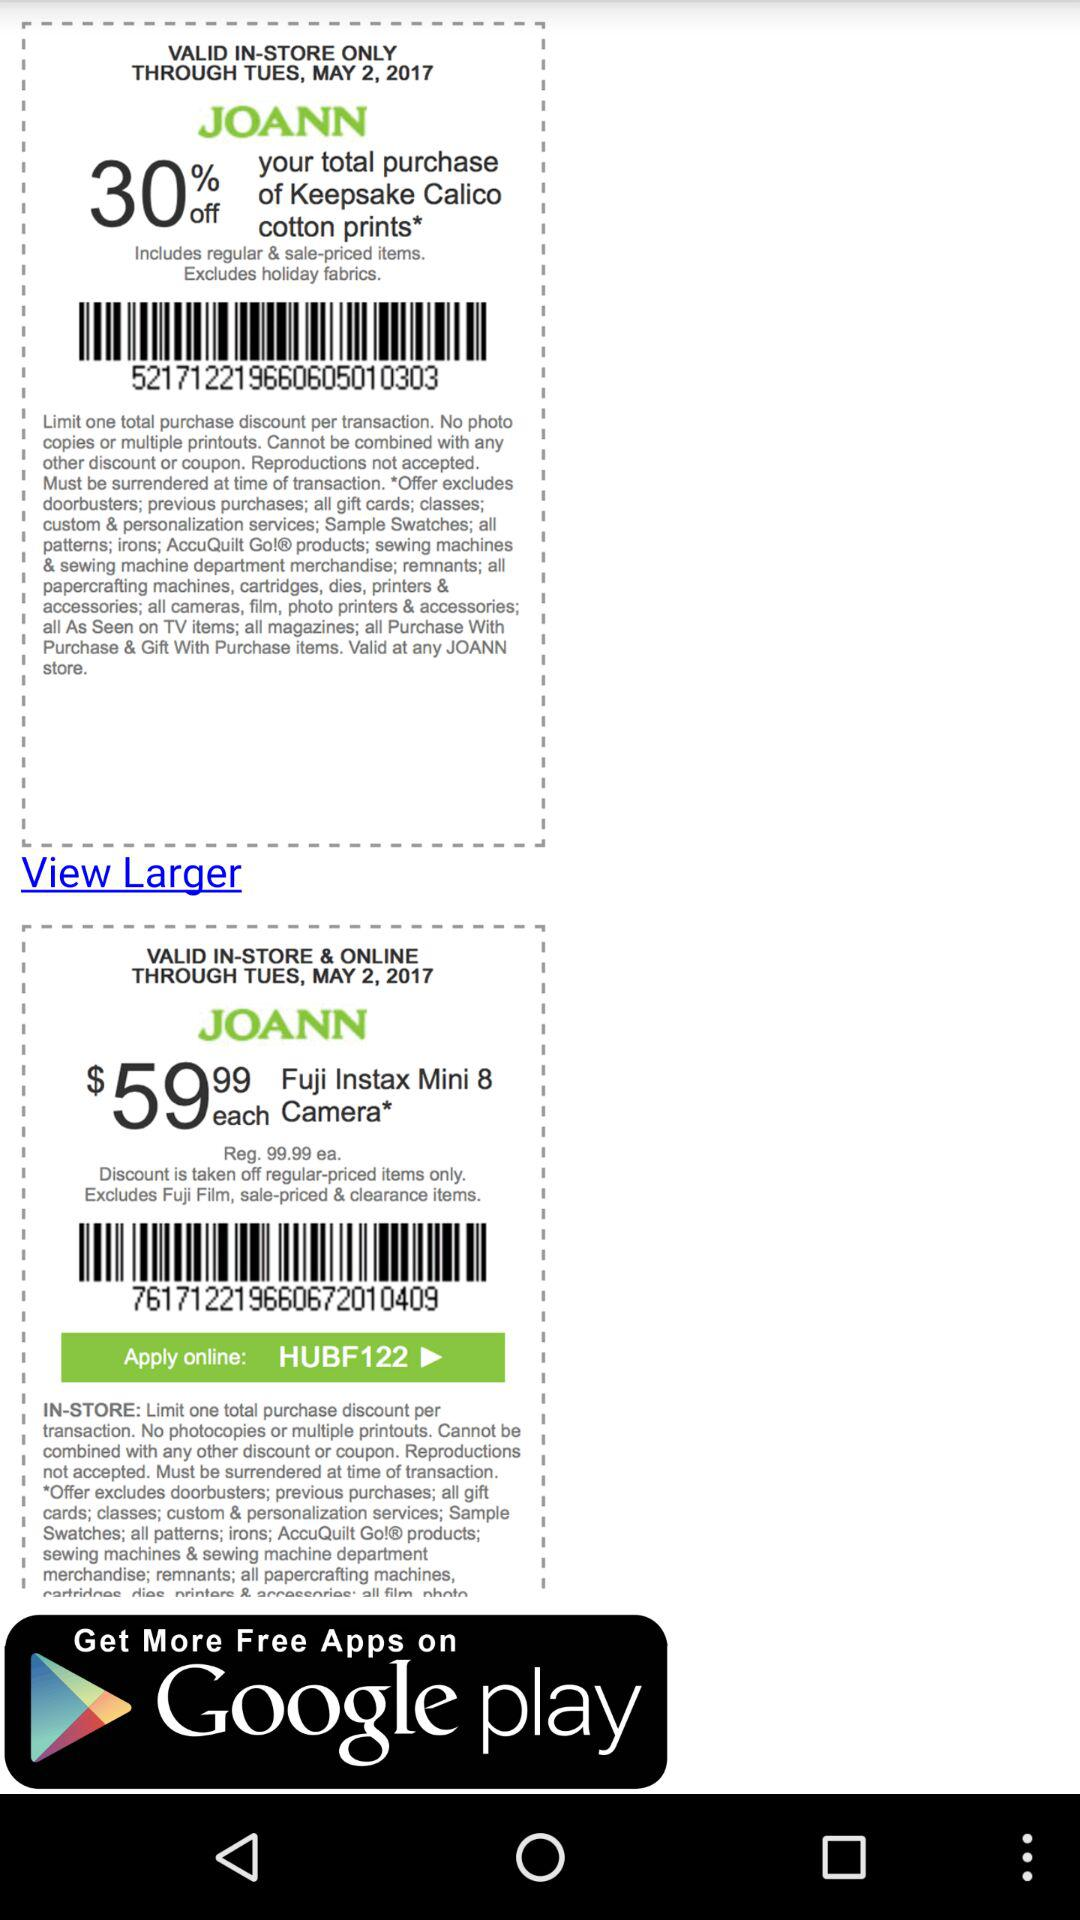How much is the discount on the first coupon?
Answer the question using a single word or phrase. 30% 